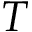Convert formula to latex. <formula><loc_0><loc_0><loc_500><loc_500>T</formula> 